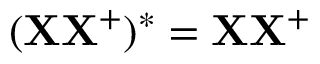Convert formula to latex. <formula><loc_0><loc_0><loc_500><loc_500>( X X ^ { + } ) ^ { * } = X X ^ { + }</formula> 